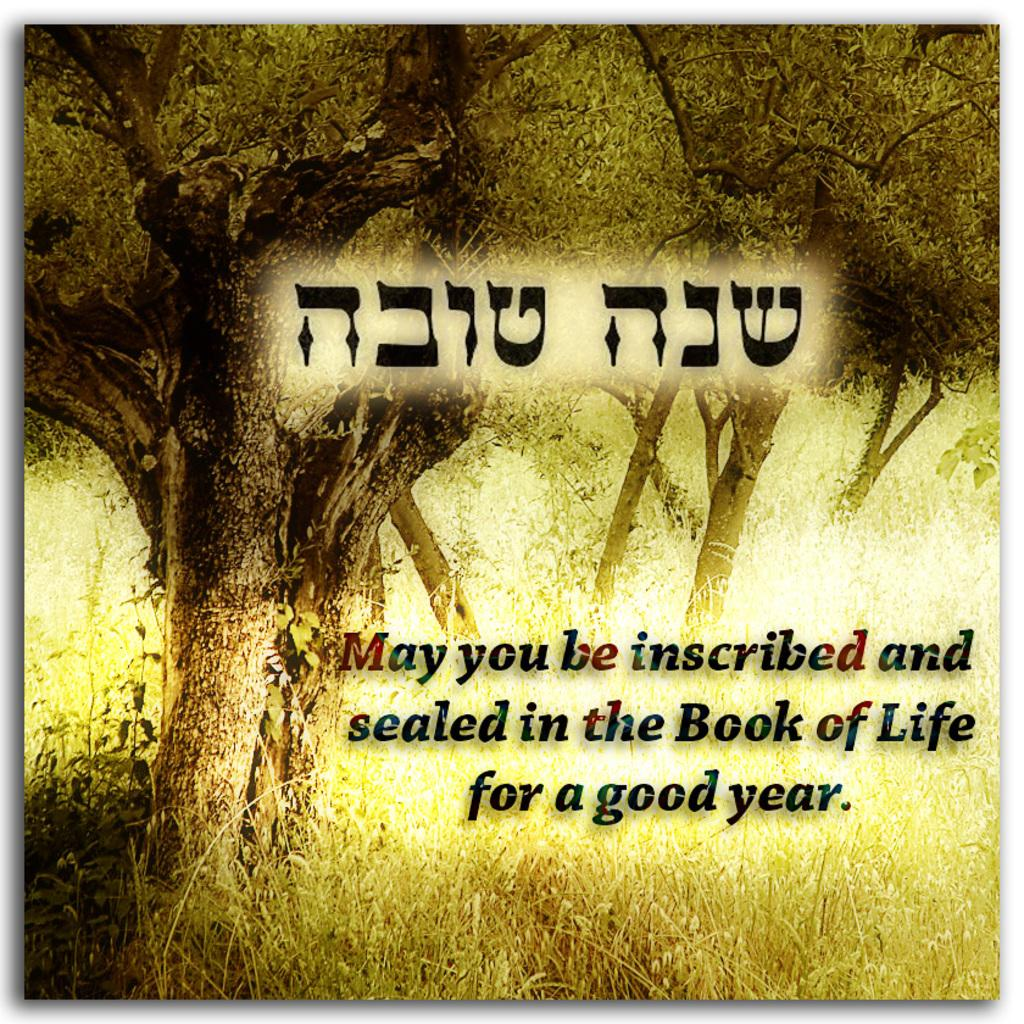What type of vegetation can be seen in the image? There are trees and plants in the image. What is the color of the text in the image? The text in the image is written in black letters. Can you see a dog carrying a basket in the image? No, there is no dog or basket present in the image. Are there any worms visible in the image? No, there are no worms visible in the image. 